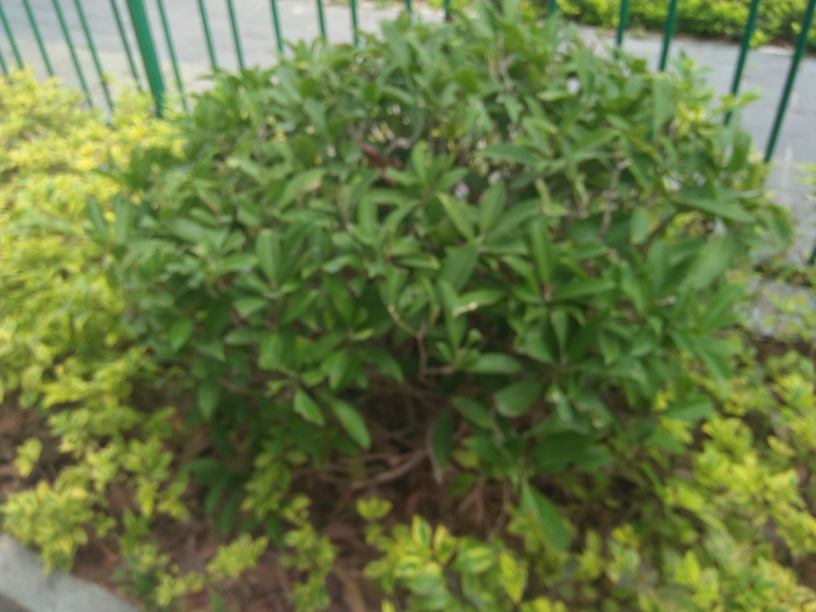What kind of plants are visible in this picture? Due to the blurriness of the image, it’s difficult to identify the specific types of plants with certainty. However, we can observe a variety of shrubbery, possibly including some evergreen species, surrounded by lighter green ground cover which might be some form of ornamental foliage. 